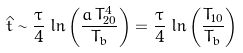<formula> <loc_0><loc_0><loc_500><loc_500>\hat { t } \sim \frac { \tau } { 4 } \, \ln \left ( \frac { a \, T _ { 2 0 } ^ { 4 } } { T _ { b } } \right ) = \frac { \tau } { 4 } \, \ln \left ( \frac { T _ { 1 0 } } { T _ { b } } \right )</formula> 